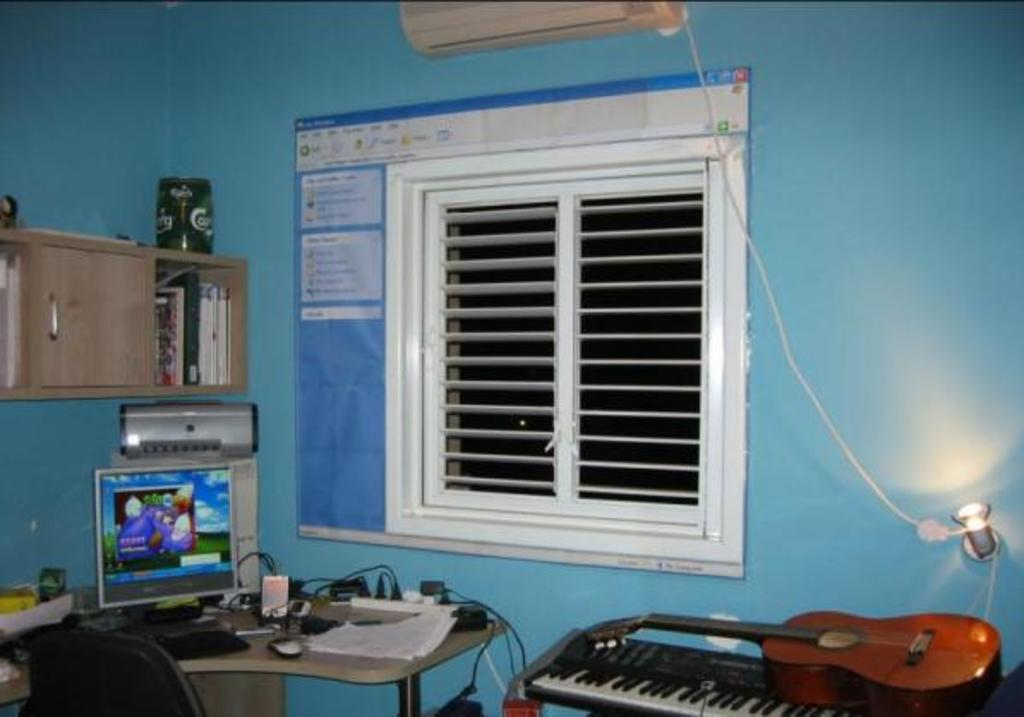What electronic device can be seen on a table in the image? There is a computer on a table in the image. What musical instruments are present in the image? There is a piano and a guitar in the image. What architectural feature is visible in the image? There is a window in the wall. What is placed on top of the window? There is a bookshelf on top of the window. How does the grandmother grip the arm of the piano in the image? There is no grandmother or arm present in the image; it only features a computer, a piano, a guitar, a window, and a bookshelf. 